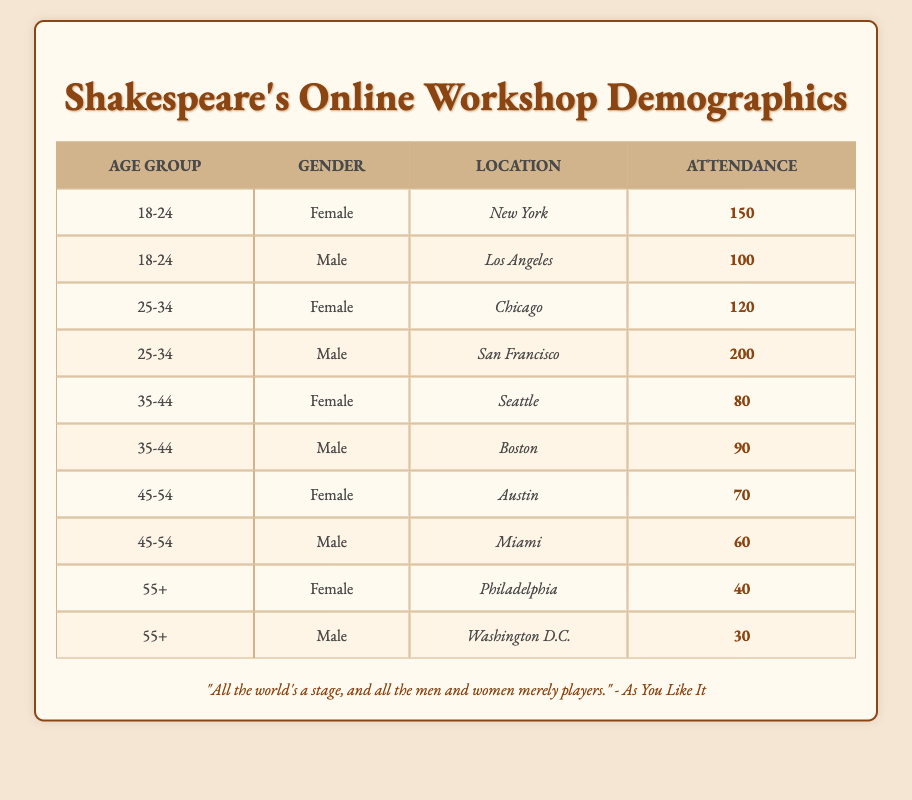What is the total attendance for the 25-34 age group? To find the total attendance for the 25-34 age group, we look at the two rows corresponding to this age group in the table. Female attendance from Chicago is 120, and Male attendance from San Francisco is 200. Adding these values: 120 + 200 = 320.
Answer: 320 Which location had the highest female attendance? Reviewing the table, we can see Female attendance values for various locations: New York (150), Chicago (120), Seattle (80), Austin (70), and Philadelphia (40). The highest value is 150 from New York.
Answer: New York Are there more attendees in the 18-24 age group than in the 55+ age group? We compare the total attendance of both age groups. The 18-24 age group has Female (150) and Male (100), summing to 250. The 55+ age group has Female (40) and Male (30), summing to 70. Since 250 is greater than 70, the statement is true.
Answer: Yes What is the average attendance for males across all age groups? First, we sum the attendance of all males: 100 (18-24) + 200 (25-34) + 90 (35-44) + 60 (45-54) + 30 (55+) = 580. There are 5 male age groups, so we divide: 580 / 5 = 116.
Answer: 116 Is the total attendance for females higher than that of males? We calculate the total attendance for females: 150 (18-24) + 120 (25-34) + 80 (35-44) + 70 (45-54) + 40 (55+) = 460. For males, the total attendance counts as 100 (18-24) + 200 (25-34) + 90 (35-44) + 60 (45-54) + 30 (55+) = 580. Since 460 is less than 580, the statement is false.
Answer: No What percentage of attendees aged 45-54 are male? We need to find the attendance for both males and females in this age group. The Female attendance is 70 and Male attendance is 60, summing to 130. The percentage of male attendance is calculated as (60 / 130) * 100, which equals approximately 46.15%.
Answer: 46.15% 